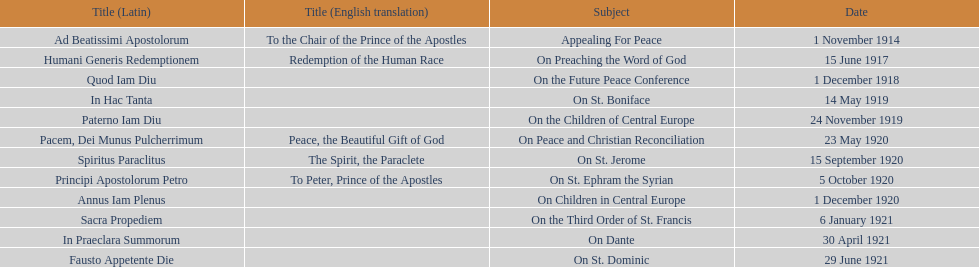What are the number of titles with a date of november? 2. 